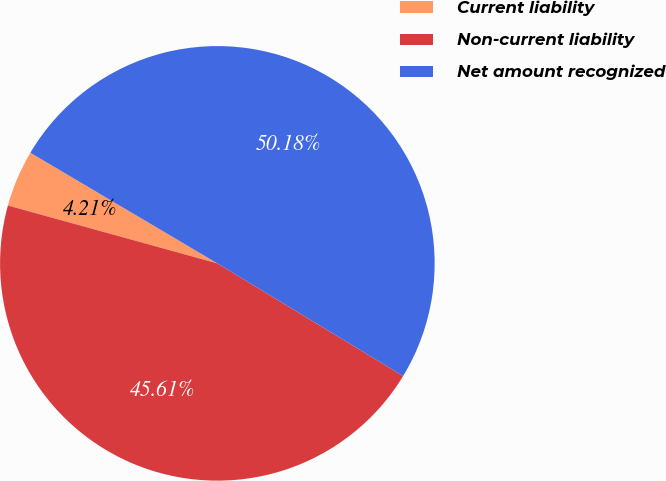Convert chart. <chart><loc_0><loc_0><loc_500><loc_500><pie_chart><fcel>Current liability<fcel>Non-current liability<fcel>Net amount recognized<nl><fcel>4.21%<fcel>45.61%<fcel>50.17%<nl></chart> 